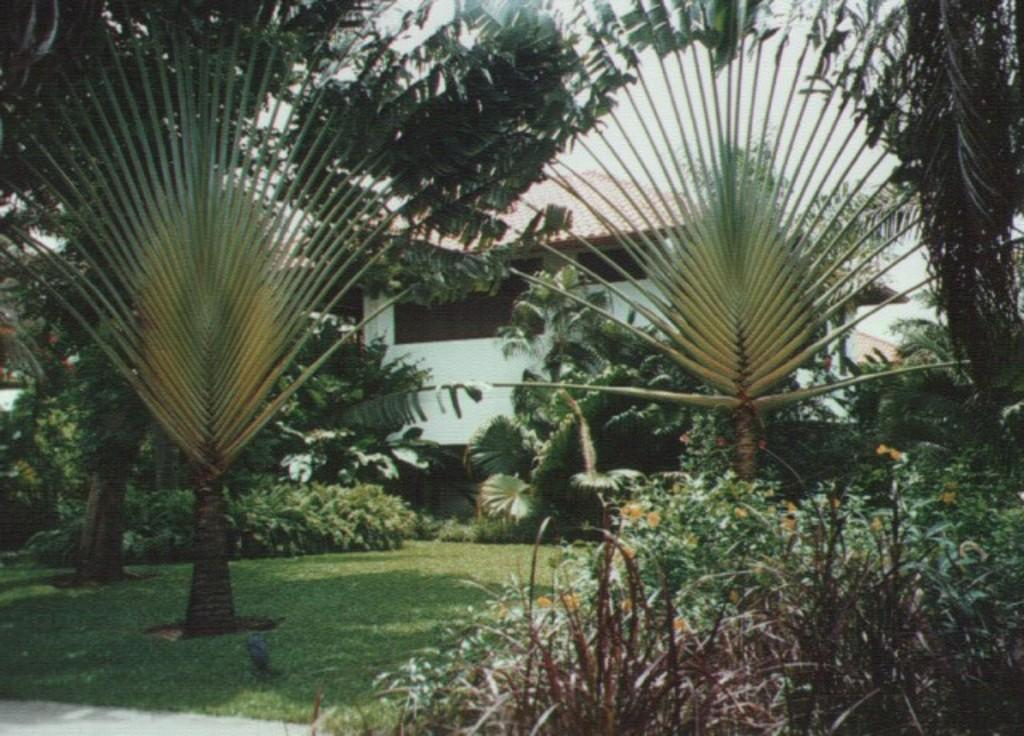What type of vegetation can be seen in the image? There are trees, grass, and plants in the image. What type of structure is present in the image? There is a building in the image. What can be seen in the background of the image? The sky is visible in the background of the image. Is there a maid visible in the image? There is no maid present in the image. Can you tell me the credit score of the person who took the picture? There is no information about the credit score of the person who took the picture, as it is not relevant to the image. 